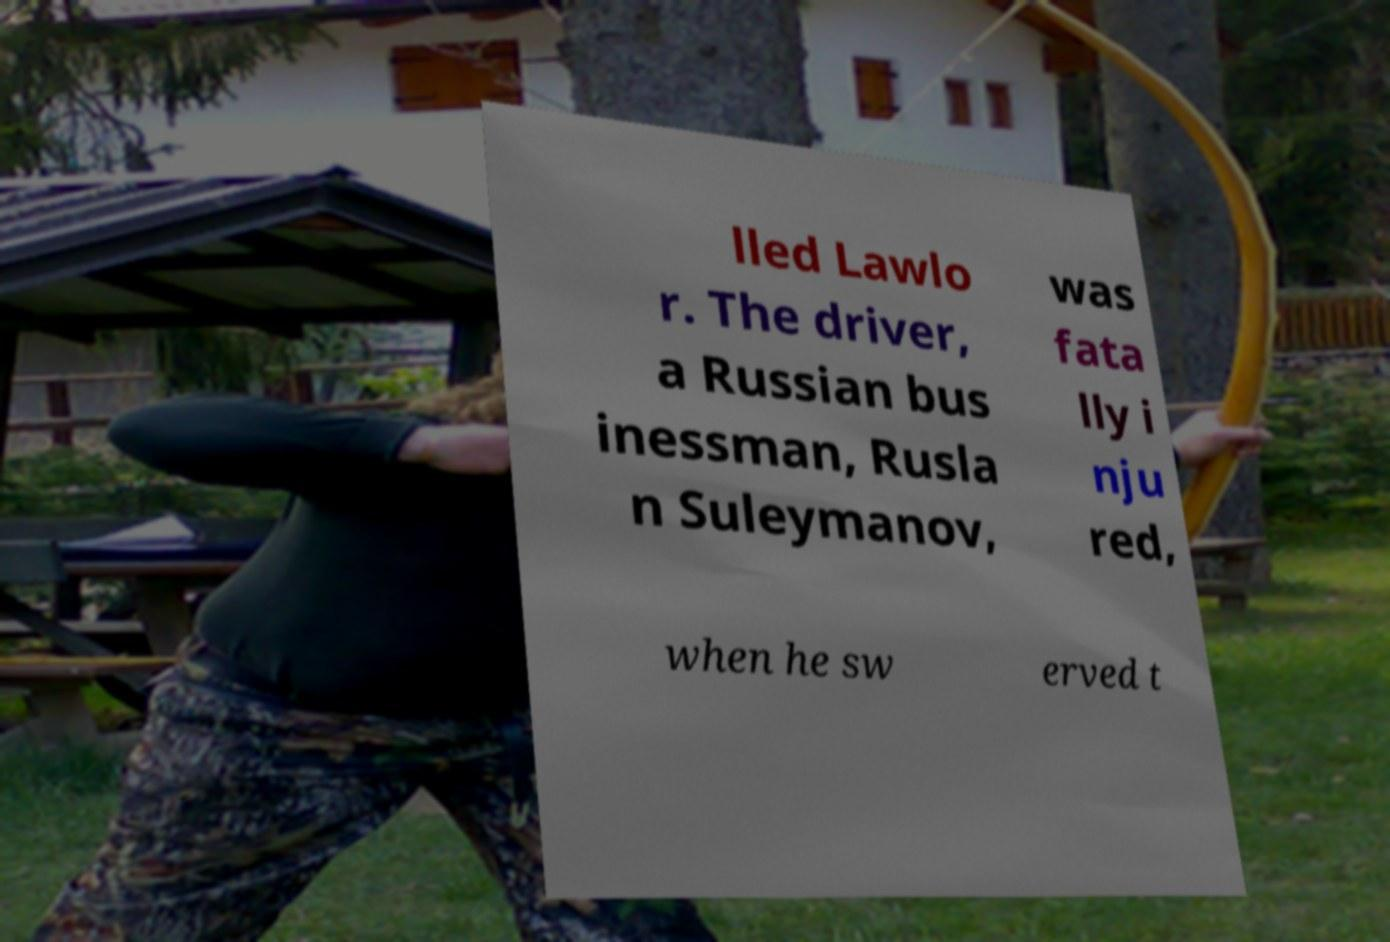Could you extract and type out the text from this image? lled Lawlo r. The driver, a Russian bus inessman, Rusla n Suleymanov, was fata lly i nju red, when he sw erved t 